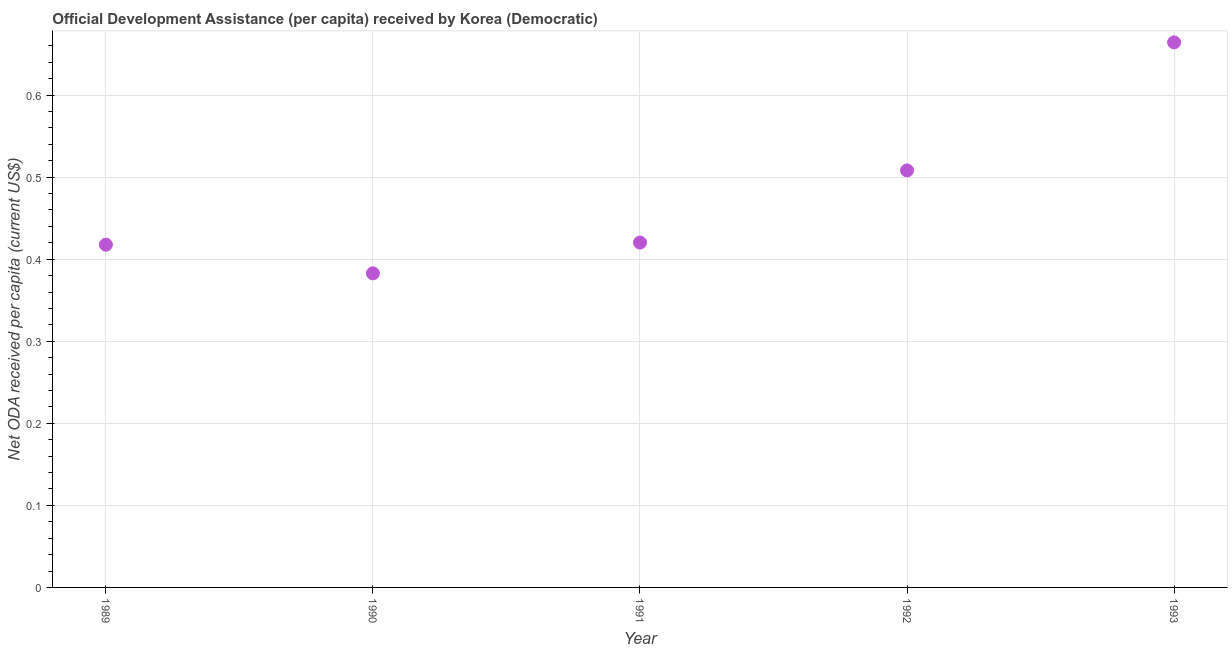What is the net oda received per capita in 1992?
Make the answer very short. 0.51. Across all years, what is the maximum net oda received per capita?
Offer a very short reply. 0.66. Across all years, what is the minimum net oda received per capita?
Your answer should be compact. 0.38. What is the sum of the net oda received per capita?
Your response must be concise. 2.39. What is the difference between the net oda received per capita in 1990 and 1992?
Your answer should be compact. -0.13. What is the average net oda received per capita per year?
Make the answer very short. 0.48. What is the median net oda received per capita?
Your answer should be compact. 0.42. Do a majority of the years between 1993 and 1990 (inclusive) have net oda received per capita greater than 0.2 US$?
Your response must be concise. Yes. What is the ratio of the net oda received per capita in 1989 to that in 1990?
Provide a succinct answer. 1.09. What is the difference between the highest and the second highest net oda received per capita?
Your response must be concise. 0.16. What is the difference between the highest and the lowest net oda received per capita?
Offer a very short reply. 0.28. In how many years, is the net oda received per capita greater than the average net oda received per capita taken over all years?
Offer a terse response. 2. Does the net oda received per capita monotonically increase over the years?
Give a very brief answer. No. How many dotlines are there?
Give a very brief answer. 1. How many years are there in the graph?
Give a very brief answer. 5. What is the difference between two consecutive major ticks on the Y-axis?
Offer a terse response. 0.1. Does the graph contain grids?
Offer a very short reply. Yes. What is the title of the graph?
Make the answer very short. Official Development Assistance (per capita) received by Korea (Democratic). What is the label or title of the X-axis?
Give a very brief answer. Year. What is the label or title of the Y-axis?
Make the answer very short. Net ODA received per capita (current US$). What is the Net ODA received per capita (current US$) in 1989?
Provide a succinct answer. 0.42. What is the Net ODA received per capita (current US$) in 1990?
Keep it short and to the point. 0.38. What is the Net ODA received per capita (current US$) in 1991?
Provide a short and direct response. 0.42. What is the Net ODA received per capita (current US$) in 1992?
Offer a terse response. 0.51. What is the Net ODA received per capita (current US$) in 1993?
Your answer should be very brief. 0.66. What is the difference between the Net ODA received per capita (current US$) in 1989 and 1990?
Ensure brevity in your answer.  0.03. What is the difference between the Net ODA received per capita (current US$) in 1989 and 1991?
Your answer should be very brief. -0. What is the difference between the Net ODA received per capita (current US$) in 1989 and 1992?
Offer a terse response. -0.09. What is the difference between the Net ODA received per capita (current US$) in 1989 and 1993?
Offer a terse response. -0.25. What is the difference between the Net ODA received per capita (current US$) in 1990 and 1991?
Your response must be concise. -0.04. What is the difference between the Net ODA received per capita (current US$) in 1990 and 1992?
Give a very brief answer. -0.13. What is the difference between the Net ODA received per capita (current US$) in 1990 and 1993?
Your answer should be very brief. -0.28. What is the difference between the Net ODA received per capita (current US$) in 1991 and 1992?
Your response must be concise. -0.09. What is the difference between the Net ODA received per capita (current US$) in 1991 and 1993?
Provide a succinct answer. -0.24. What is the difference between the Net ODA received per capita (current US$) in 1992 and 1993?
Make the answer very short. -0.16. What is the ratio of the Net ODA received per capita (current US$) in 1989 to that in 1990?
Offer a very short reply. 1.09. What is the ratio of the Net ODA received per capita (current US$) in 1989 to that in 1991?
Keep it short and to the point. 0.99. What is the ratio of the Net ODA received per capita (current US$) in 1989 to that in 1992?
Your response must be concise. 0.82. What is the ratio of the Net ODA received per capita (current US$) in 1989 to that in 1993?
Your response must be concise. 0.63. What is the ratio of the Net ODA received per capita (current US$) in 1990 to that in 1991?
Offer a very short reply. 0.91. What is the ratio of the Net ODA received per capita (current US$) in 1990 to that in 1992?
Offer a terse response. 0.75. What is the ratio of the Net ODA received per capita (current US$) in 1990 to that in 1993?
Your answer should be compact. 0.58. What is the ratio of the Net ODA received per capita (current US$) in 1991 to that in 1992?
Give a very brief answer. 0.83. What is the ratio of the Net ODA received per capita (current US$) in 1991 to that in 1993?
Ensure brevity in your answer.  0.63. What is the ratio of the Net ODA received per capita (current US$) in 1992 to that in 1993?
Your answer should be compact. 0.77. 